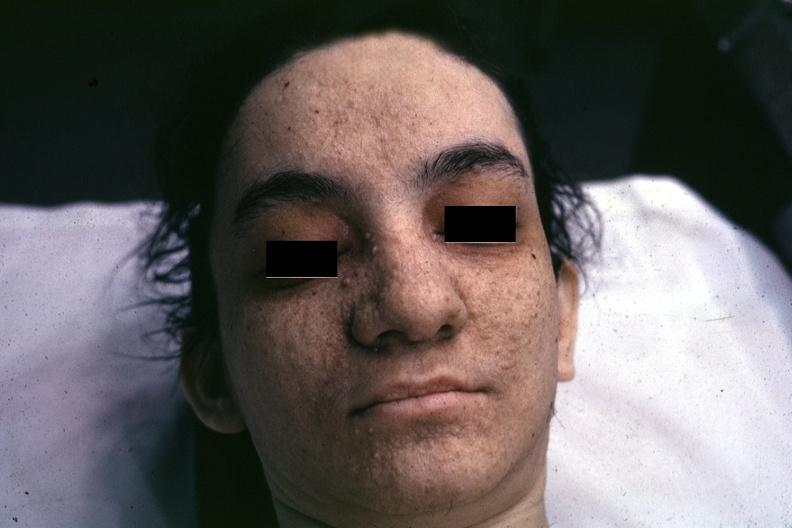how is very good example associated with sclerosis?
Answer the question using a single word or phrase. Tuberous 